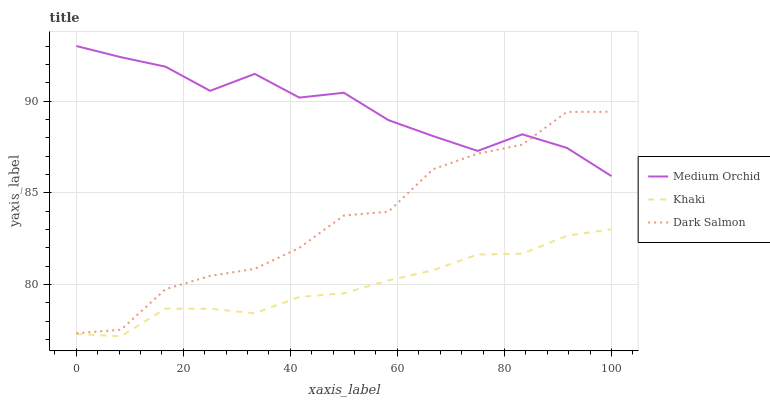Does Khaki have the minimum area under the curve?
Answer yes or no. Yes. Does Medium Orchid have the maximum area under the curve?
Answer yes or no. Yes. Does Dark Salmon have the minimum area under the curve?
Answer yes or no. No. Does Dark Salmon have the maximum area under the curve?
Answer yes or no. No. Is Khaki the smoothest?
Answer yes or no. Yes. Is Dark Salmon the roughest?
Answer yes or no. Yes. Is Dark Salmon the smoothest?
Answer yes or no. No. Is Khaki the roughest?
Answer yes or no. No. Does Khaki have the lowest value?
Answer yes or no. Yes. Does Dark Salmon have the lowest value?
Answer yes or no. No. Does Medium Orchid have the highest value?
Answer yes or no. Yes. Does Dark Salmon have the highest value?
Answer yes or no. No. Is Khaki less than Medium Orchid?
Answer yes or no. Yes. Is Medium Orchid greater than Khaki?
Answer yes or no. Yes. Does Dark Salmon intersect Medium Orchid?
Answer yes or no. Yes. Is Dark Salmon less than Medium Orchid?
Answer yes or no. No. Is Dark Salmon greater than Medium Orchid?
Answer yes or no. No. Does Khaki intersect Medium Orchid?
Answer yes or no. No. 